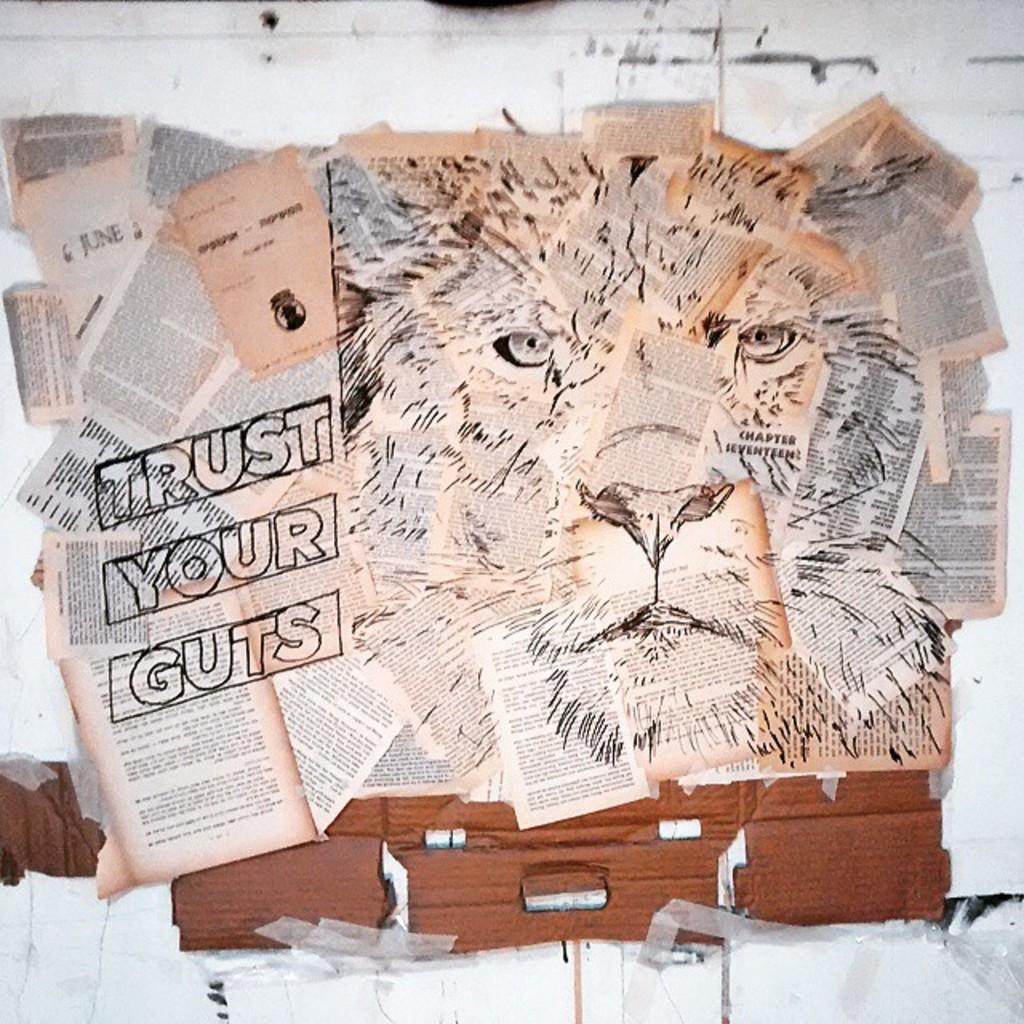What animal is the main subject of the image? The main subject of the image is a lion. How is the lion depicted in the image? The lion is created with papers. What else can be seen on the lion besides its paper body? There is text on the lion. How many houses can be seen in the image? There are no houses present in the image; it features a lion made of paper with text on it. What is the taste of the lion in the image? The lion in the image is made of paper and does not have a taste. 